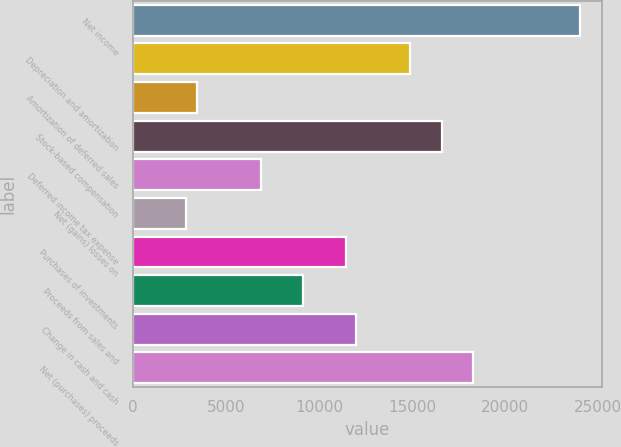<chart> <loc_0><loc_0><loc_500><loc_500><bar_chart><fcel>Net income<fcel>Depreciation and amortization<fcel>Amortization of deferred sales<fcel>Stock-based compensation<fcel>Deferred income tax expense<fcel>Net (gains) losses on<fcel>Purchases of investments<fcel>Proceeds from sales and<fcel>Change in cash and cash<fcel>Net (purchases) proceeds<nl><fcel>24033.4<fcel>14878.2<fcel>3434.2<fcel>16594.8<fcel>6867.4<fcel>2862<fcel>11445<fcel>9156.2<fcel>12017.2<fcel>18311.4<nl></chart> 